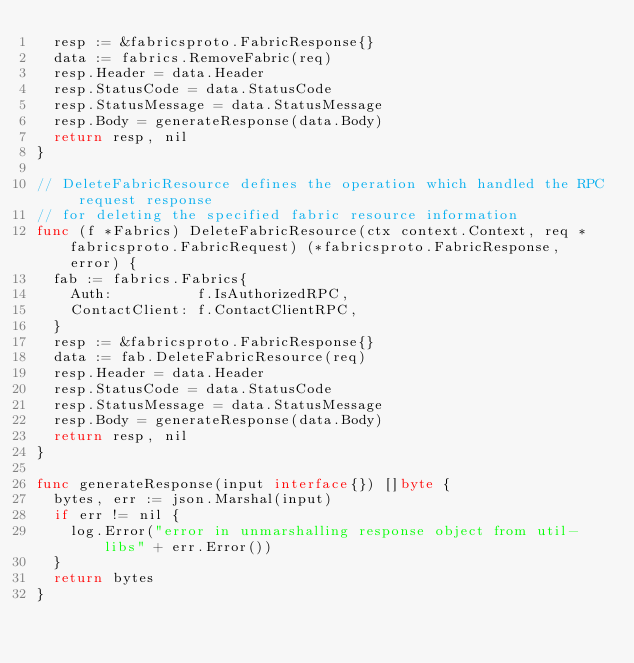Convert code to text. <code><loc_0><loc_0><loc_500><loc_500><_Go_>	resp := &fabricsproto.FabricResponse{}
	data := fabrics.RemoveFabric(req)
	resp.Header = data.Header
	resp.StatusCode = data.StatusCode
	resp.StatusMessage = data.StatusMessage
	resp.Body = generateResponse(data.Body)
	return resp, nil
}

// DeleteFabricResource defines the operation which handled the RPC request response
// for deleting the specified fabric resource information
func (f *Fabrics) DeleteFabricResource(ctx context.Context, req *fabricsproto.FabricRequest) (*fabricsproto.FabricResponse, error) {
	fab := fabrics.Fabrics{
		Auth:          f.IsAuthorizedRPC,
		ContactClient: f.ContactClientRPC,
	}
	resp := &fabricsproto.FabricResponse{}
	data := fab.DeleteFabricResource(req)
	resp.Header = data.Header
	resp.StatusCode = data.StatusCode
	resp.StatusMessage = data.StatusMessage
	resp.Body = generateResponse(data.Body)
	return resp, nil
}

func generateResponse(input interface{}) []byte {
	bytes, err := json.Marshal(input)
	if err != nil {
		log.Error("error in unmarshalling response object from util-libs" + err.Error())
	}
	return bytes
}
</code> 